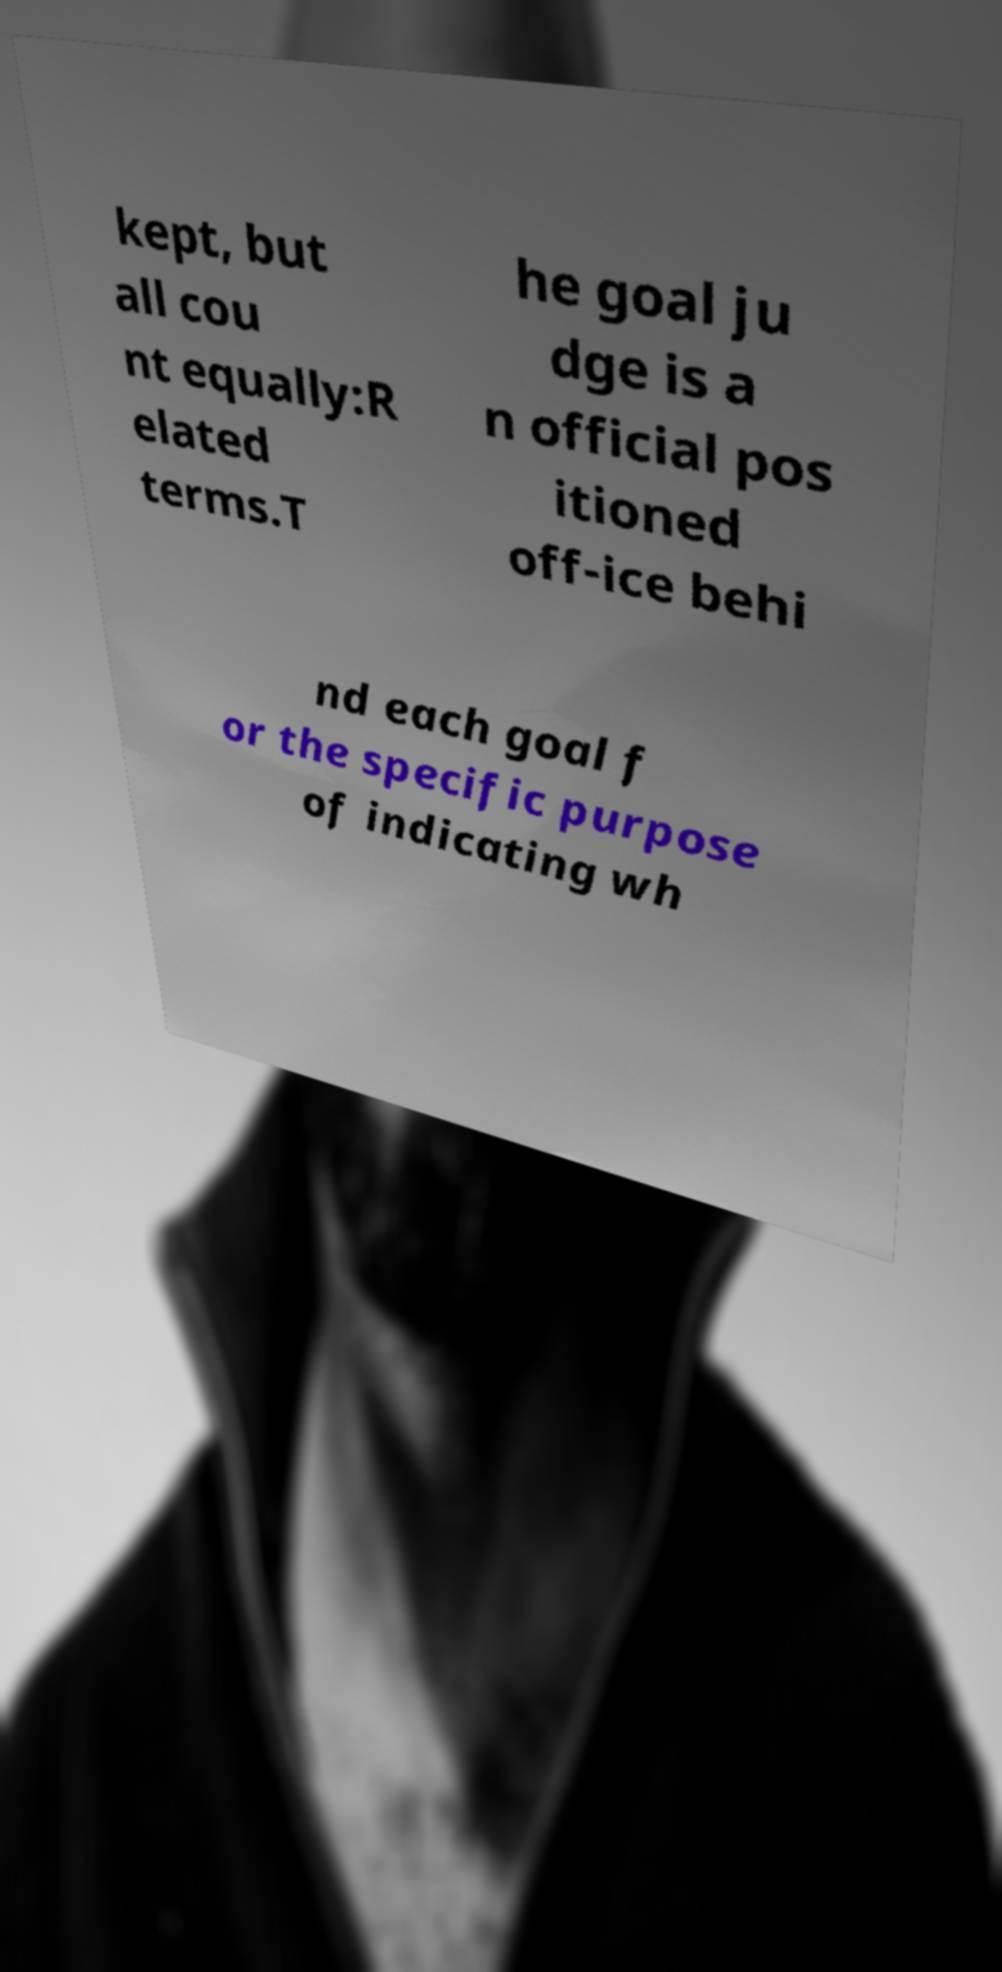Please identify and transcribe the text found in this image. kept, but all cou nt equally:R elated terms.T he goal ju dge is a n official pos itioned off-ice behi nd each goal f or the specific purpose of indicating wh 